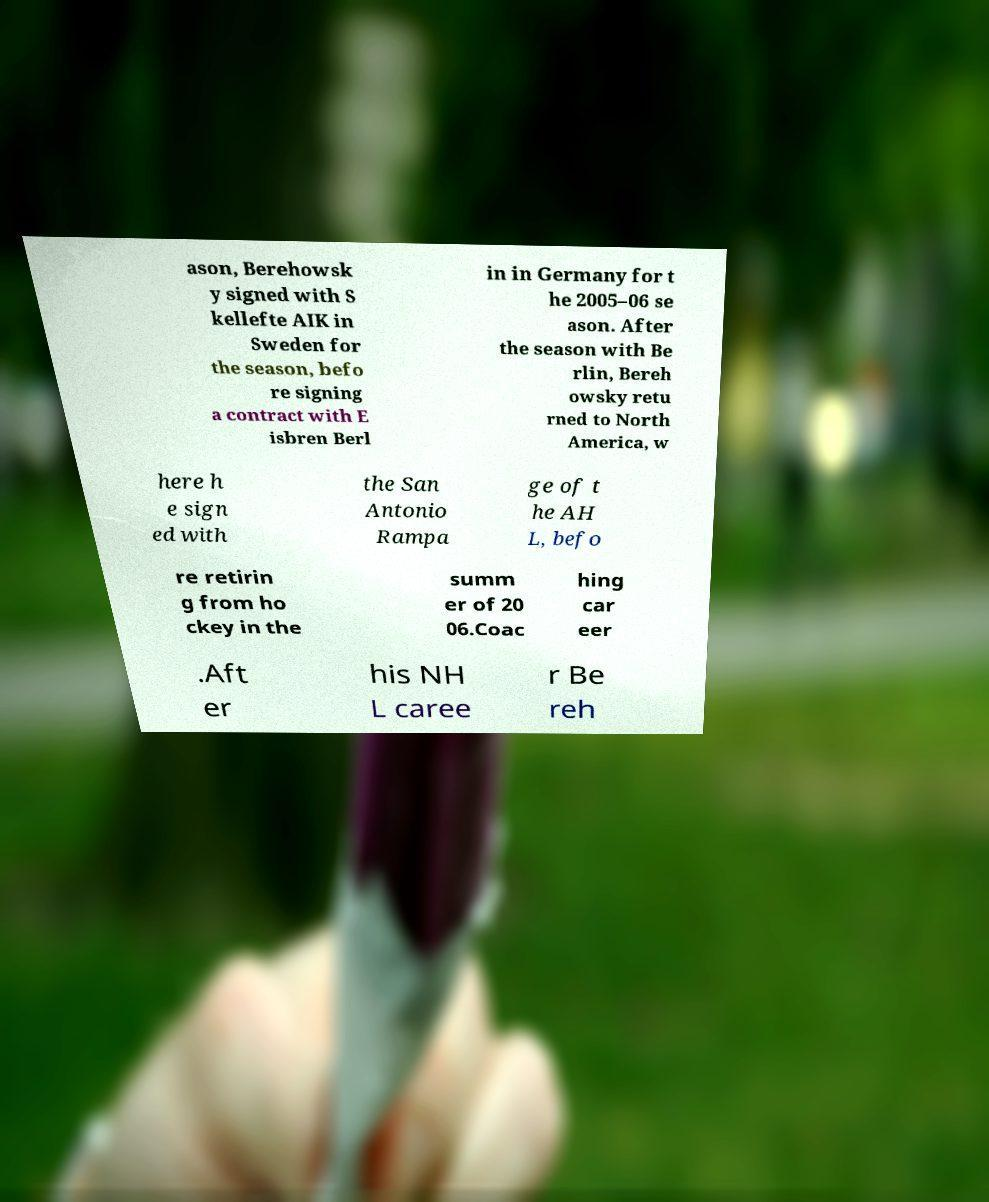Please read and relay the text visible in this image. What does it say? ason, Berehowsk y signed with S kellefte AIK in Sweden for the season, befo re signing a contract with E isbren Berl in in Germany for t he 2005–06 se ason. After the season with Be rlin, Bereh owsky retu rned to North America, w here h e sign ed with the San Antonio Rampa ge of t he AH L, befo re retirin g from ho ckey in the summ er of 20 06.Coac hing car eer .Aft er his NH L caree r Be reh 